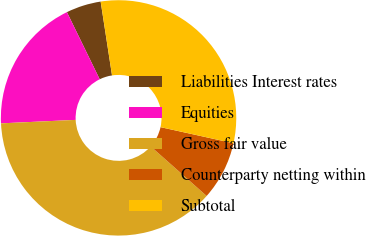Convert chart to OTSL. <chart><loc_0><loc_0><loc_500><loc_500><pie_chart><fcel>Liabilities Interest rates<fcel>Equities<fcel>Gross fair value<fcel>Counterparty netting within<fcel>Subtotal<nl><fcel>4.8%<fcel>18.51%<fcel>37.72%<fcel>8.09%<fcel>30.89%<nl></chart> 